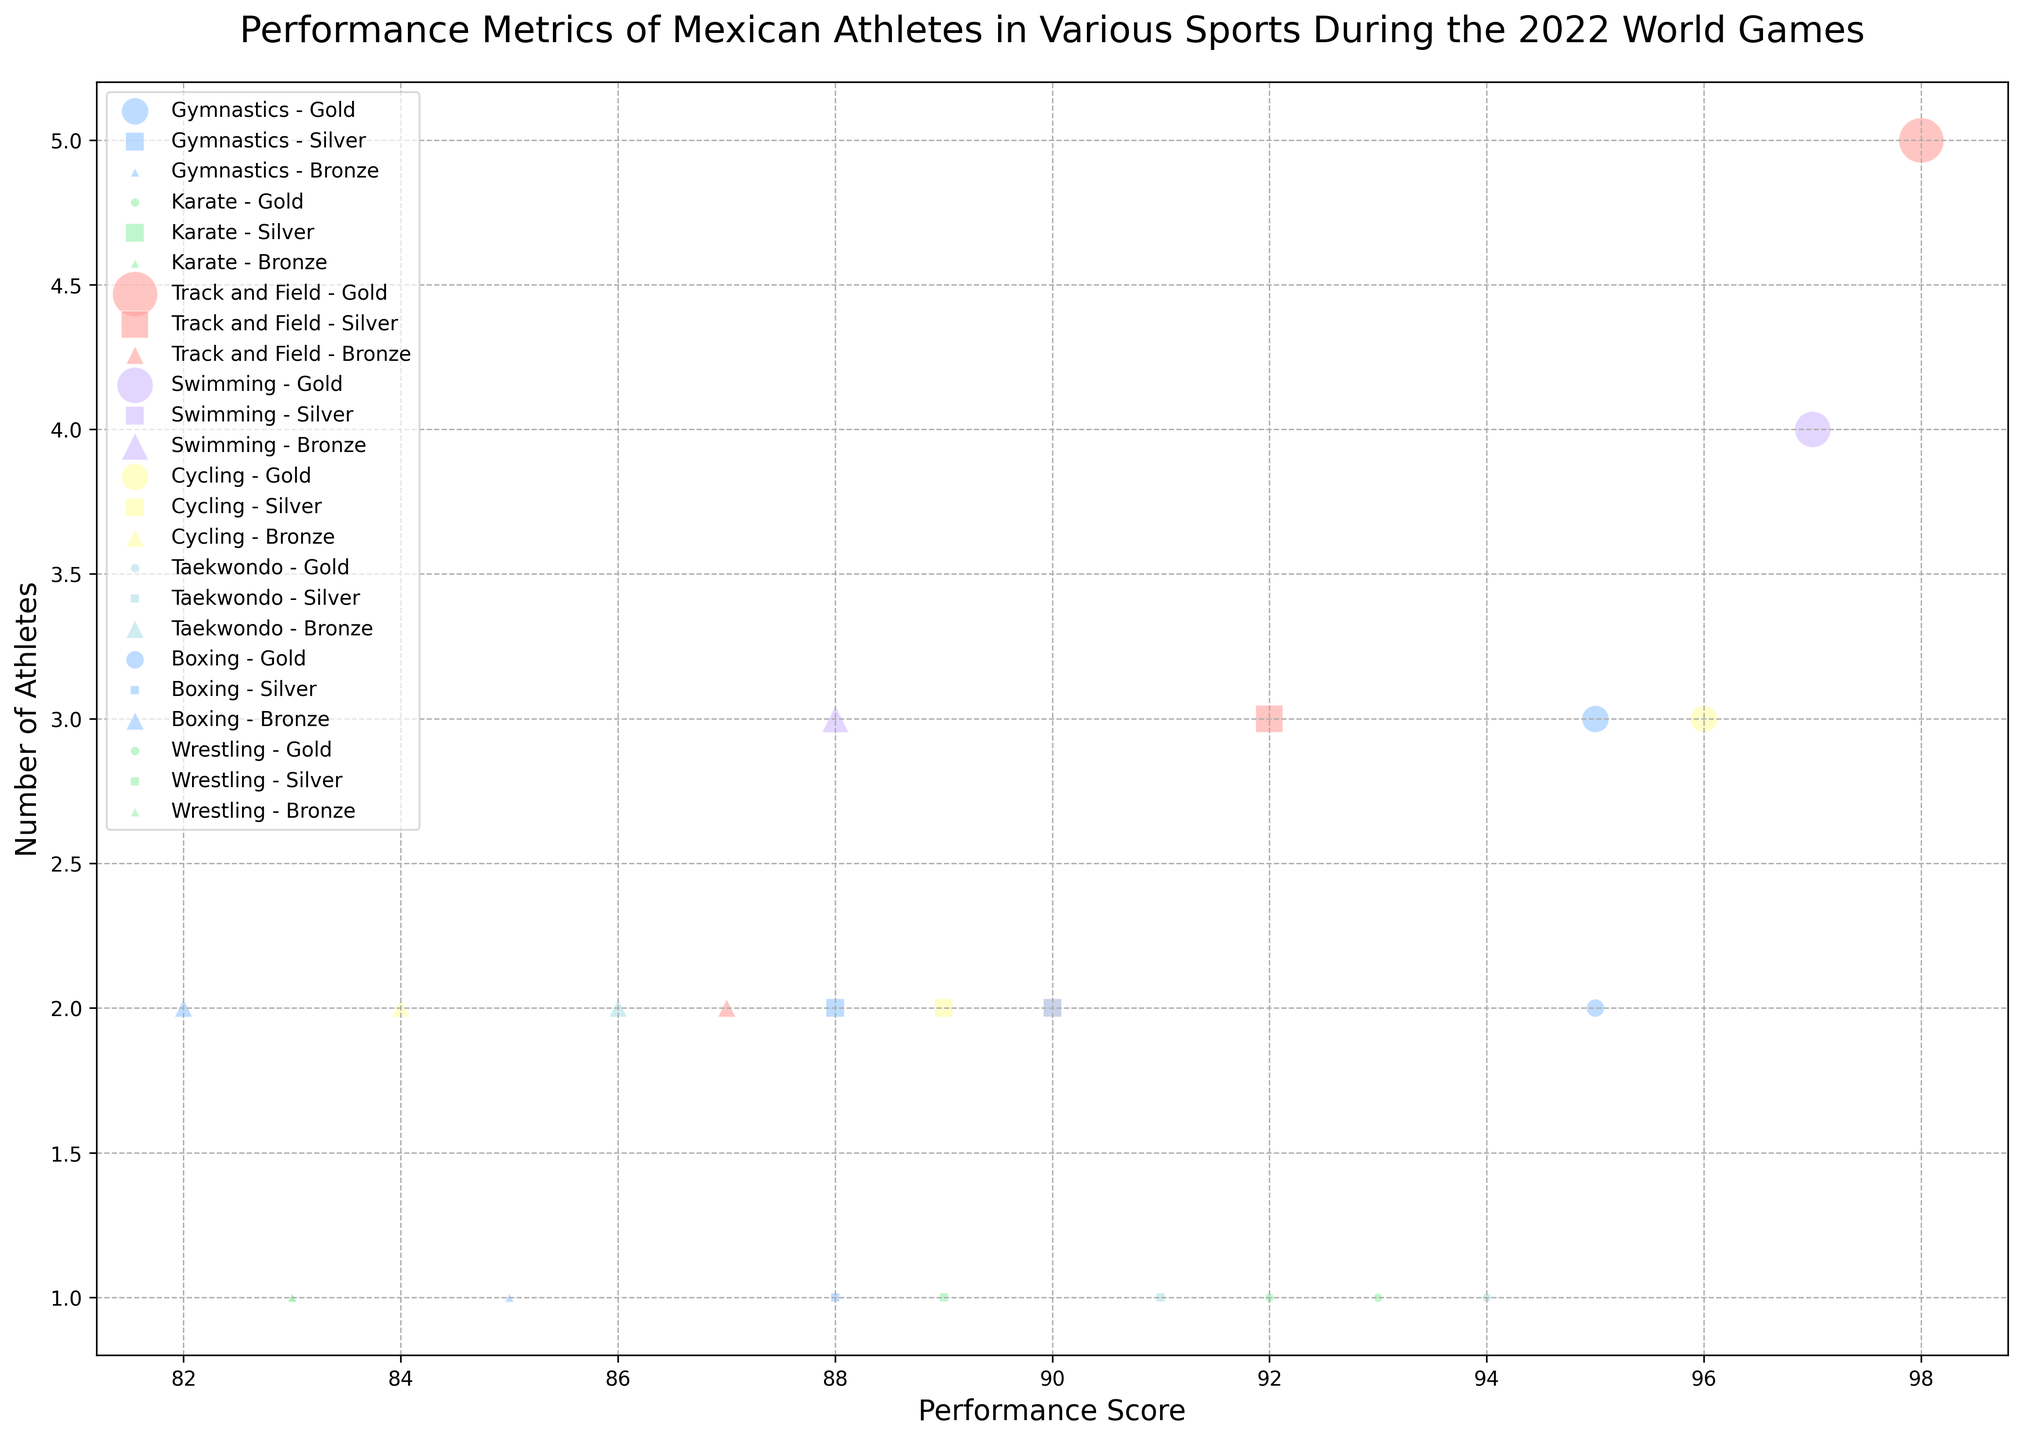What sport has the highest performance score for gold medals? The highest performance score for gold medals can be found by looking for the largest bubble on the x-axis (performance score) among the gold medal markers (circles). Track and Field has a performance score of 98, the highest among all gold medalists.
Answer: Track and Field Which sport has the most athletes winning gold medals? To find the sport with the most gold medalists, look for the largest bubbles among the gold medal markers (circles) representing the number of athletes. Track and Field has the largest bubble for gold medals with 5 athletes.
Answer: Track and Field What is the total number of athletes who won medals in Swimming? To find the total number of athletes in Swimming, sum the number of athletes from gold, silver, and bronze medals. Swimming has gold (4), silver (2), and bronze (3) medalists. So, 4 + 2 + 3 = 9.
Answer: 9 Which sport had the lowest performance score for bronze medals? Compare the performance scores of all bronze medalists (triangles) to find the lowest. Boxing has the lowest performance score for bronze at 82.
Answer: Boxing How does the number of gold medalists in Boxing compare to that in Wrestling? To compare, locate the number of athletes for gold medals in Boxing and Wrestling. Boxing has 2 gold medal athletes, while Wrestling has 1. Hence, Boxing has more gold medalists than Wrestling.
Answer: Boxing has more Which sport had gold medalists with a performance score close to 95? Look for circles (gold medalists) around the performance score of 95. Gymnastics (95) and Boxing (95) have gold medalists with performance scores close to 95.
Answer: Gymnastics and Boxing What is the average performance score of bronze medalists in Gymnastics and Wrestling? To find the average, sum the performance scores of bronze medalists in Gymnastics and Wrestling, then divide by the number of scores. Gymnastics has 85 and Wrestling has 83. (85 + 83) / 2 = 84.
Answer: 84 Which sport and medal type had the smallest number of athletes with a performance score above 90? Identify the smallest bubbles with performance scores above 90, focusing on all three medal types. Karate silver and Taekwondo gold each have 1 athlete with performance scores of 90 and 94 respectively, but only Karate silver is exactly 90.
Answer: Karate silver Between Swimming and Cycling, which sport has higher performance scores for bronze medals on average? Calculate the average performance score for bronze medals in Swimming and Cycling. Swimming has scores (88, 3 athletes) and Cycling has scores (84, 2 athletes). For Swimming: 88 / 3 = 29.33; for Cycling: 84 / 2 = 42. Both are divided by the number of athletes, the average for Swimming = 88, for Cycling = 84.
Answer: Swimming What is the total number of silver medals won in Track and Field and Karate? To find the total, sum the number of athletes with silver medals in both Track and Field and Karate. Track and Field has 3 silver medalists, and Karate has 2. 3 + 2 = 5.
Answer: 5 